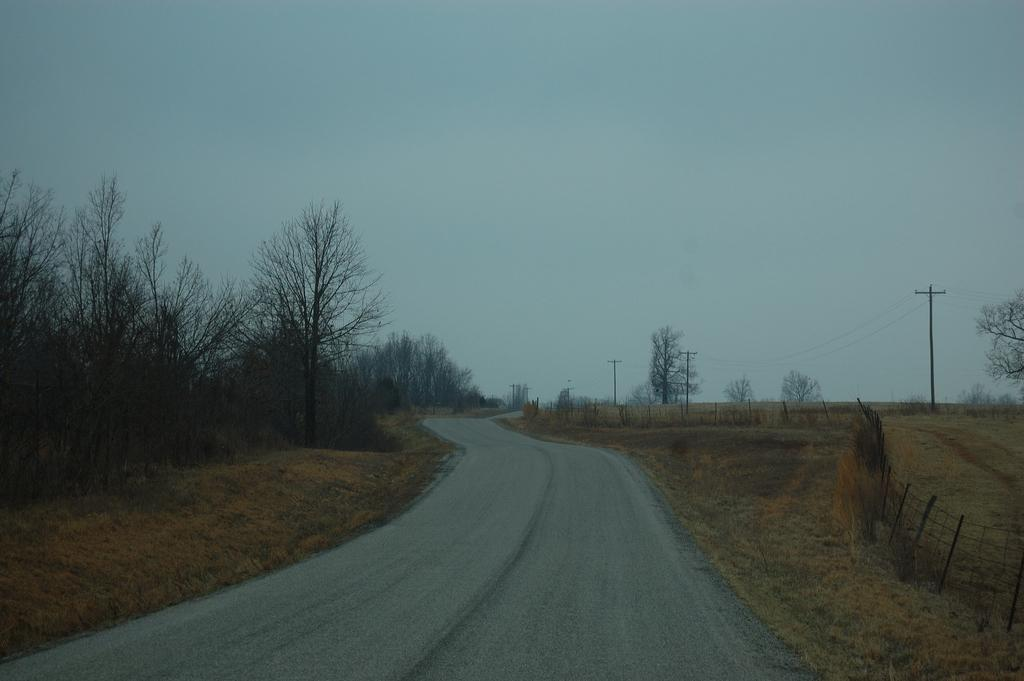What type of pathway is visible in the image? There is a road in the image. What type of vegetation can be seen in the image? There are trees and grass in the image. What structures are present on the right side of the image? There are current poles and a fence on the right side of the image. What is visible in the background of the image? The sky is visible in the background of the image. What type of tramp is visible in the image? There is no tramp present in the image. What type of earth can be seen in the image? The image does not show a specific type of earth; it features a road, trees, grass, current poles, a fence, and the sky. 